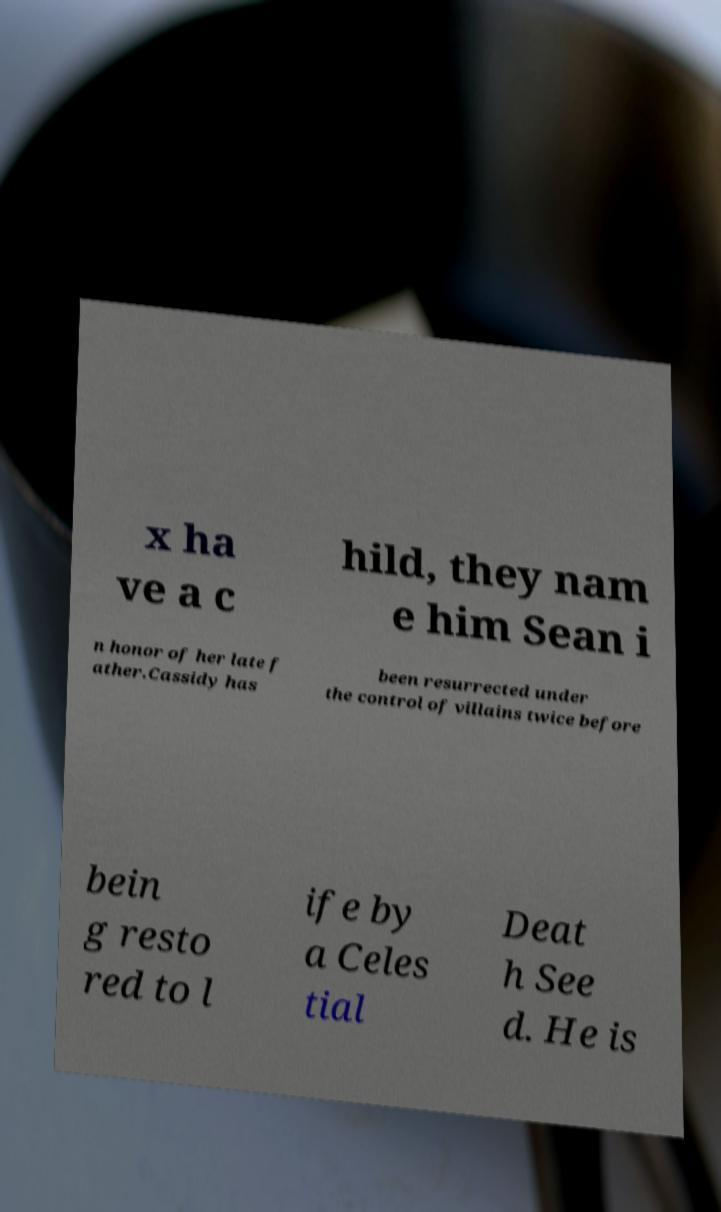I need the written content from this picture converted into text. Can you do that? x ha ve a c hild, they nam e him Sean i n honor of her late f ather.Cassidy has been resurrected under the control of villains twice before bein g resto red to l ife by a Celes tial Deat h See d. He is 